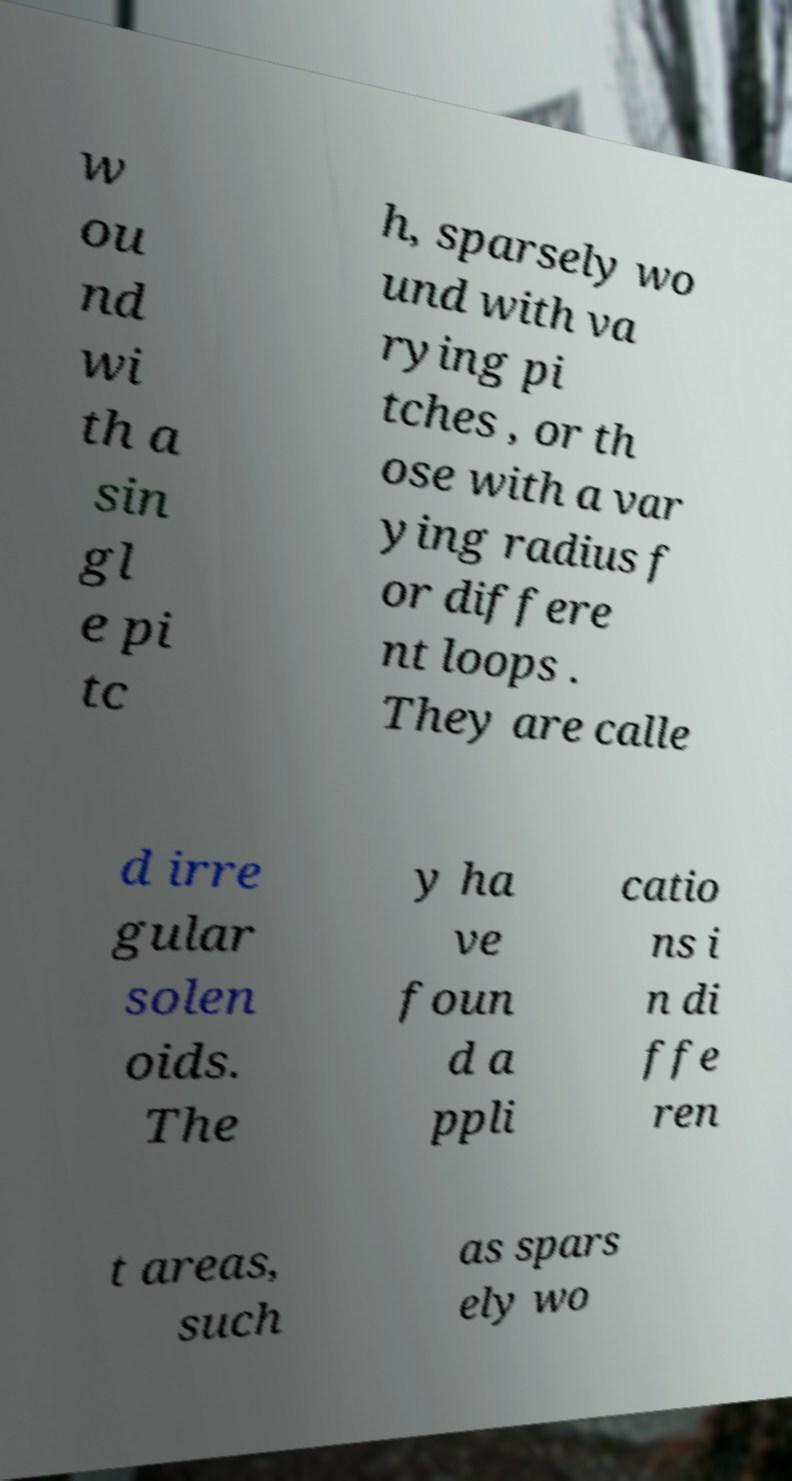Please identify and transcribe the text found in this image. w ou nd wi th a sin gl e pi tc h, sparsely wo und with va rying pi tches , or th ose with a var ying radius f or differe nt loops . They are calle d irre gular solen oids. The y ha ve foun d a ppli catio ns i n di ffe ren t areas, such as spars ely wo 